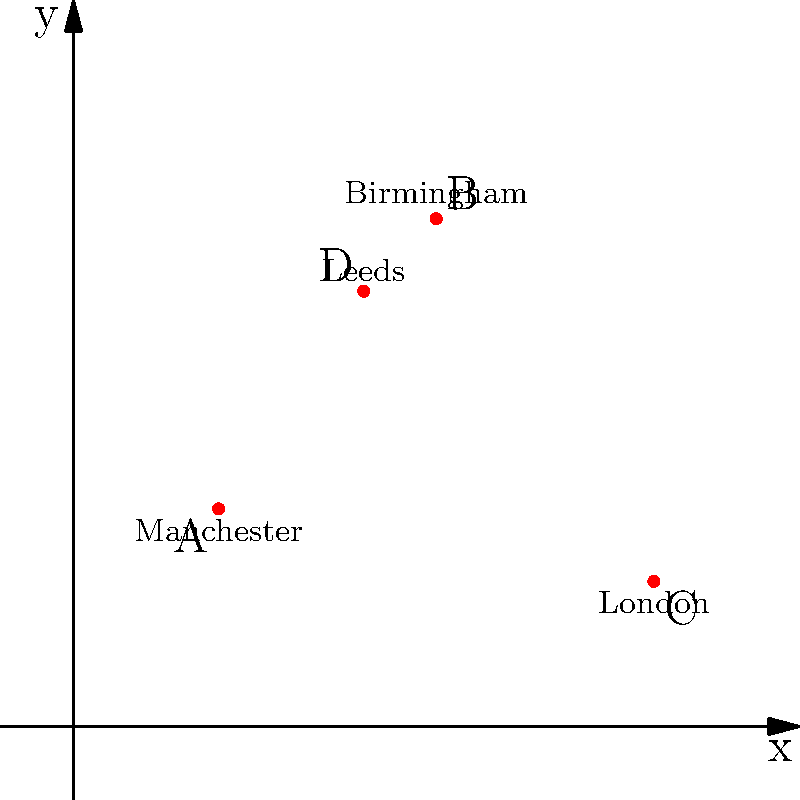As a descendant of an industrialist, you're familiar with the locations of major factories during the Industrial Revolution. The graph shows the coordinates of four significant industrial cities: Manchester (A), Birmingham (B), London (C), and Leeds (D). Calculate the total distance between these cities if you were to travel from Manchester to Birmingham, then to London, and finally to Leeds, using the distance formula $d = \sqrt{(x_2-x_1)^2 + (y_2-y_1)^2}$. Round your answer to the nearest whole number. Let's calculate the distance between each pair of cities step by step:

1. Manchester (A) to Birmingham (B):
   A(2,3) to B(5,7)
   $d_{AB} = \sqrt{(5-2)^2 + (7-3)^2} = \sqrt{3^2 + 4^2} = \sqrt{9 + 16} = \sqrt{25} = 5$

2. Birmingham (B) to London (C):
   B(5,7) to C(8,2)
   $d_{BC} = \sqrt{(8-5)^2 + (2-7)^2} = \sqrt{3^2 + (-5)^2} = \sqrt{9 + 25} = \sqrt{34} \approx 5.83$

3. London (C) to Leeds (D):
   C(8,2) to D(4,6)
   $d_{CD} = \sqrt{(4-8)^2 + (6-2)^2} = \sqrt{(-4)^2 + 4^2} = \sqrt{16 + 16} = \sqrt{32} \approx 5.66$

4. Total distance:
   $d_{total} = d_{AB} + d_{BC} + d_{CD} = 5 + 5.83 + 5.66 = 16.49$

5. Rounding to the nearest whole number:
   16.49 rounds to 16

Therefore, the total distance traveled is approximately 16 units.
Answer: 16 units 